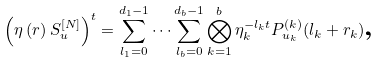Convert formula to latex. <formula><loc_0><loc_0><loc_500><loc_500>\left ( \eta \left ( r \right ) S _ { u } ^ { [ N ] } \right ) ^ { t } = \sum _ { l _ { 1 } = 0 } ^ { d _ { 1 } - 1 } \dots \sum _ { l _ { b } = 0 } ^ { d _ { b } - 1 } \bigotimes _ { k = 1 } ^ { b } \eta _ { k } ^ { - l _ { k } t } P _ { u _ { k } } ^ { \left ( k \right ) } ( l _ { k } + r _ { k } ) \text {,}</formula> 